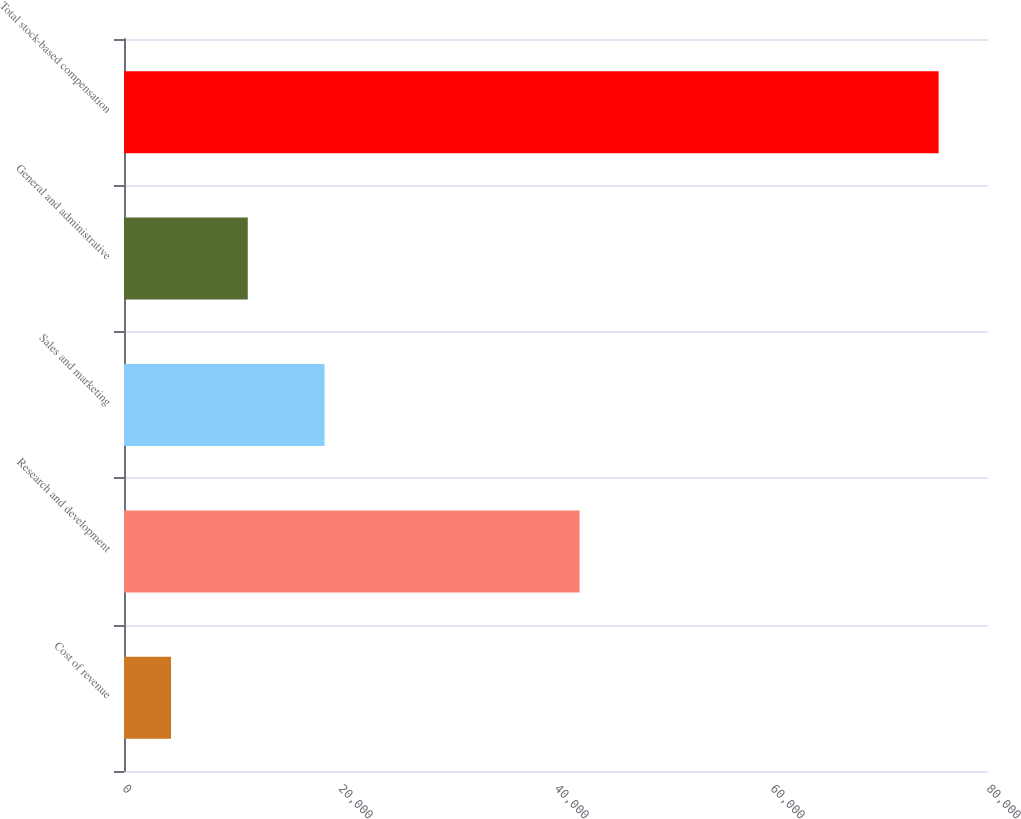Convert chart to OTSL. <chart><loc_0><loc_0><loc_500><loc_500><bar_chart><fcel>Cost of revenue<fcel>Research and development<fcel>Sales and marketing<fcel>General and administrative<fcel>Total stock-based compensation<nl><fcel>4353<fcel>42184<fcel>18567.8<fcel>11460.4<fcel>75427<nl></chart> 